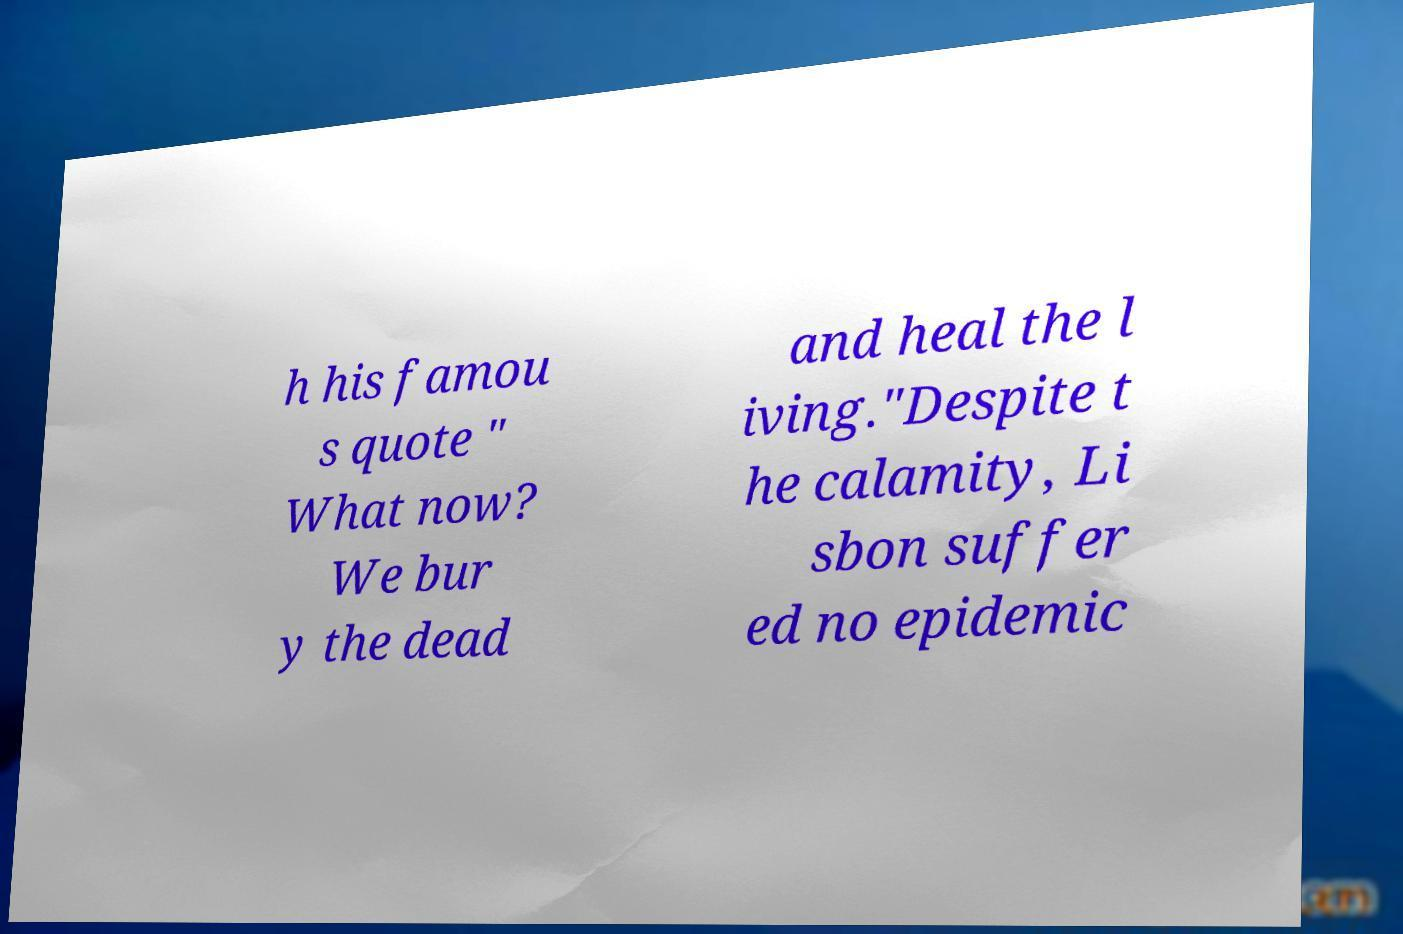Can you accurately transcribe the text from the provided image for me? h his famou s quote " What now? We bur y the dead and heal the l iving."Despite t he calamity, Li sbon suffer ed no epidemic 